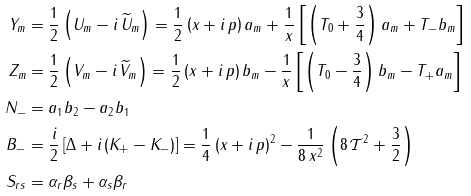<formula> <loc_0><loc_0><loc_500><loc_500>Y _ { m } & = \frac { 1 } { 2 } \left ( U _ { m } - i \, \widetilde { U } _ { m } \right ) = \frac { 1 } { 2 } \left ( x + i \, p \right ) a _ { m } + \frac { 1 } { x } \left [ \left ( T _ { 0 } + \frac { 3 } { 4 } \right ) a _ { m } + T _ { - } b _ { m } \right ] \\ Z _ { m } & = \frac { 1 } { 2 } \left ( V _ { m } - i \, \widetilde { V } _ { m } \right ) = \frac { 1 } { 2 } \left ( x + i \, p \right ) b _ { m } - \frac { 1 } { x } \left [ \left ( T _ { 0 } - \frac { 3 } { 4 } \right ) b _ { m } - T _ { + } a _ { m } \right ] \\ N _ { - } & = a _ { 1 } b _ { 2 } - a _ { 2 } b _ { 1 } \\ B _ { - } & = \frac { i } { 2 } \left [ \Delta + i \left ( K _ { + } - K _ { - } \right ) \right ] = \frac { 1 } { 4 } \left ( x + i \, p \right ) ^ { 2 } - \frac { 1 } { 8 \, x ^ { 2 } } \left ( 8 \, \mathcal { T } ^ { 2 } + \frac { 3 } { 2 } \right ) \\ S _ { r s } & = \alpha _ { r } \beta _ { s } + \alpha _ { s } \beta _ { r }</formula> 